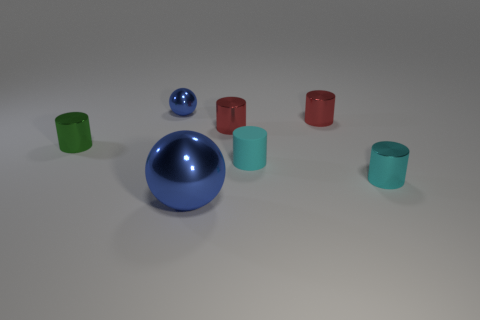Subtract all green cylinders. How many cylinders are left? 4 Subtract all cyan metallic cylinders. How many cylinders are left? 4 Subtract all yellow cylinders. Subtract all purple cubes. How many cylinders are left? 5 Add 3 tiny green things. How many objects exist? 10 Subtract all spheres. How many objects are left? 5 Add 7 small cyan things. How many small cyan things exist? 9 Subtract 0 brown balls. How many objects are left? 7 Subtract all big metallic objects. Subtract all green metallic cylinders. How many objects are left? 5 Add 3 small metallic objects. How many small metallic objects are left? 8 